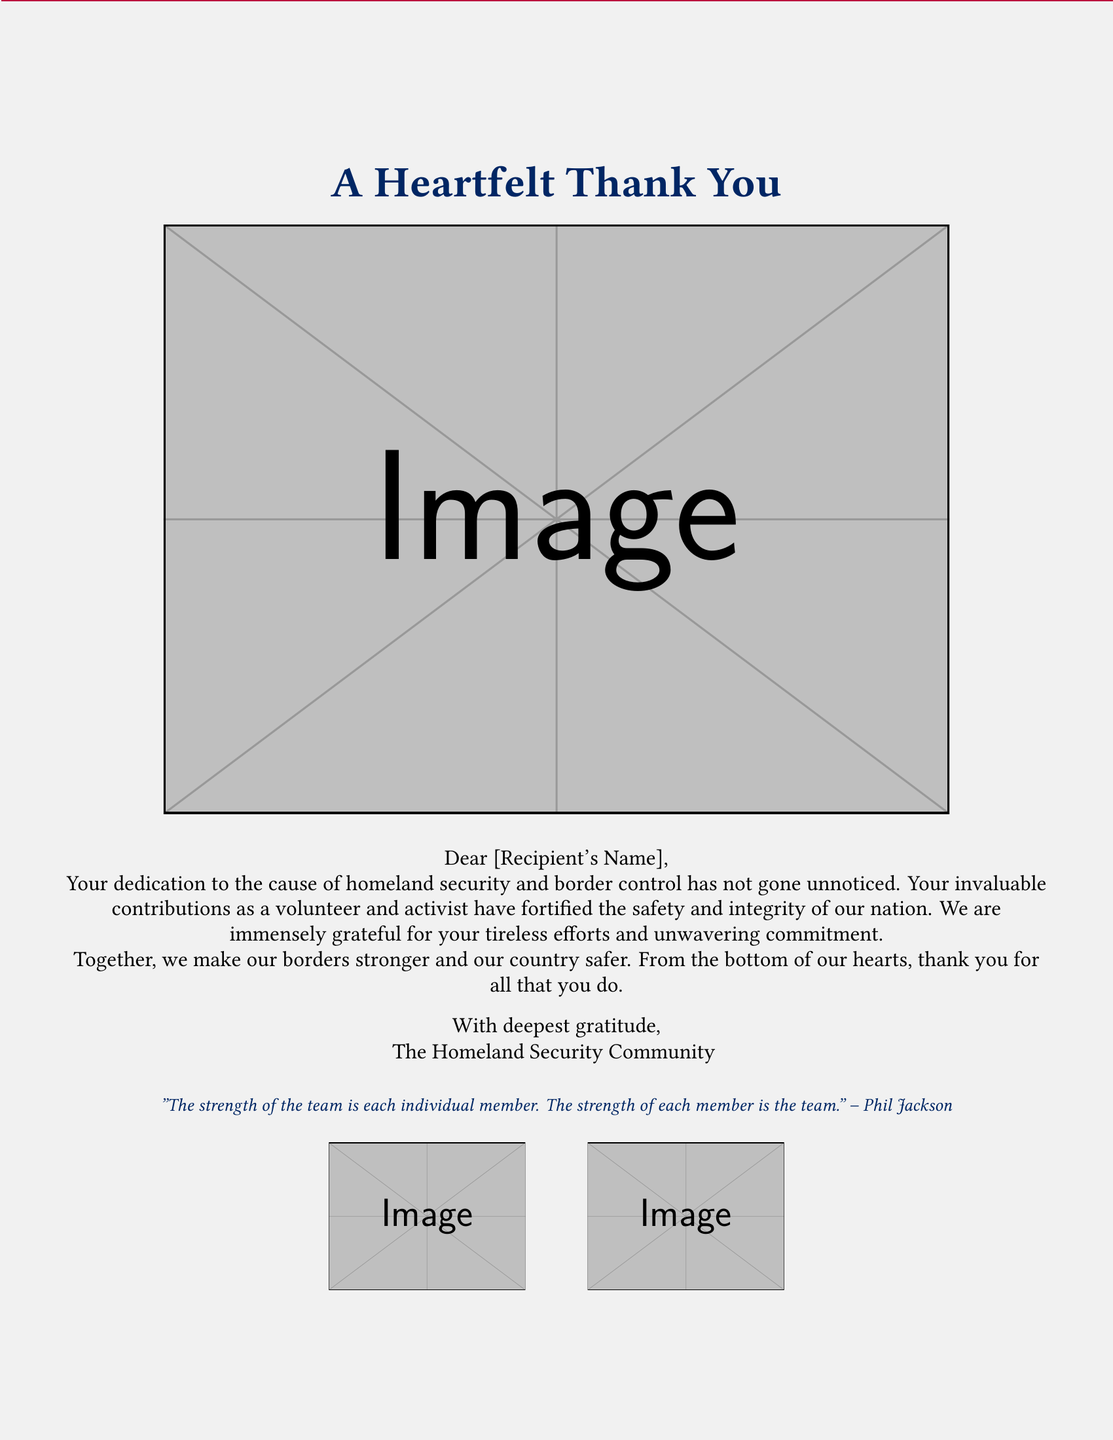What is the main title of the card? The main title is prominently displayed at the top of the card, which conveys the central message of gratitude.
Answer: A Heartfelt Thank You Who is the card addressed to? The card contains a placeholder for the recipient's name, indicating that it is personalized for an individual.
Answer: [Recipient's Name] What color is the patriotic theme of the card primarily? The card features a design with red and blue colors inspired by the American flag, indicative of its patriotic theme.
Answer: red and blue What does the card express gratitude for? The content of the card thanks the individual for their contributions towards a specific cause, highlighting their important role.
Answer: grassroots homeland security efforts Who is the sender of the card? The closing of the card identifies the group behind the message, reflecting the collective appreciation from that organization.
Answer: The Homeland Security Community What quote is included in the card? The card offers an inspirational quote that emphasizes teamwork, which reinforces the message of collaboration.
Answer: "The strength of the team is each individual member. The strength of each member is the team." – Phil Jackson What type of image is included in the card? The card prominently features an image that supports the theme of the message and honors those mentioned.
Answer: American flag and border security personnel How is the message delivered in the card? The message of gratitude is conveyed through a letter format, which is typical for personal or community notes of appreciation.
Answer: Letter format What is the significance of including border security personnel in the card's image? The inclusion of border security personnel visually emphasizes the theme of homeland security, aligning with the card's message of appreciation.
Answer: homeland security theme 